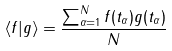Convert formula to latex. <formula><loc_0><loc_0><loc_500><loc_500>\left < f | g \right > = \frac { \sum _ { \alpha = 1 } ^ { N } f ( t _ { \alpha } ) g ( t _ { \alpha } ) } { N }</formula> 